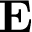<formula> <loc_0><loc_0><loc_500><loc_500>E</formula> 